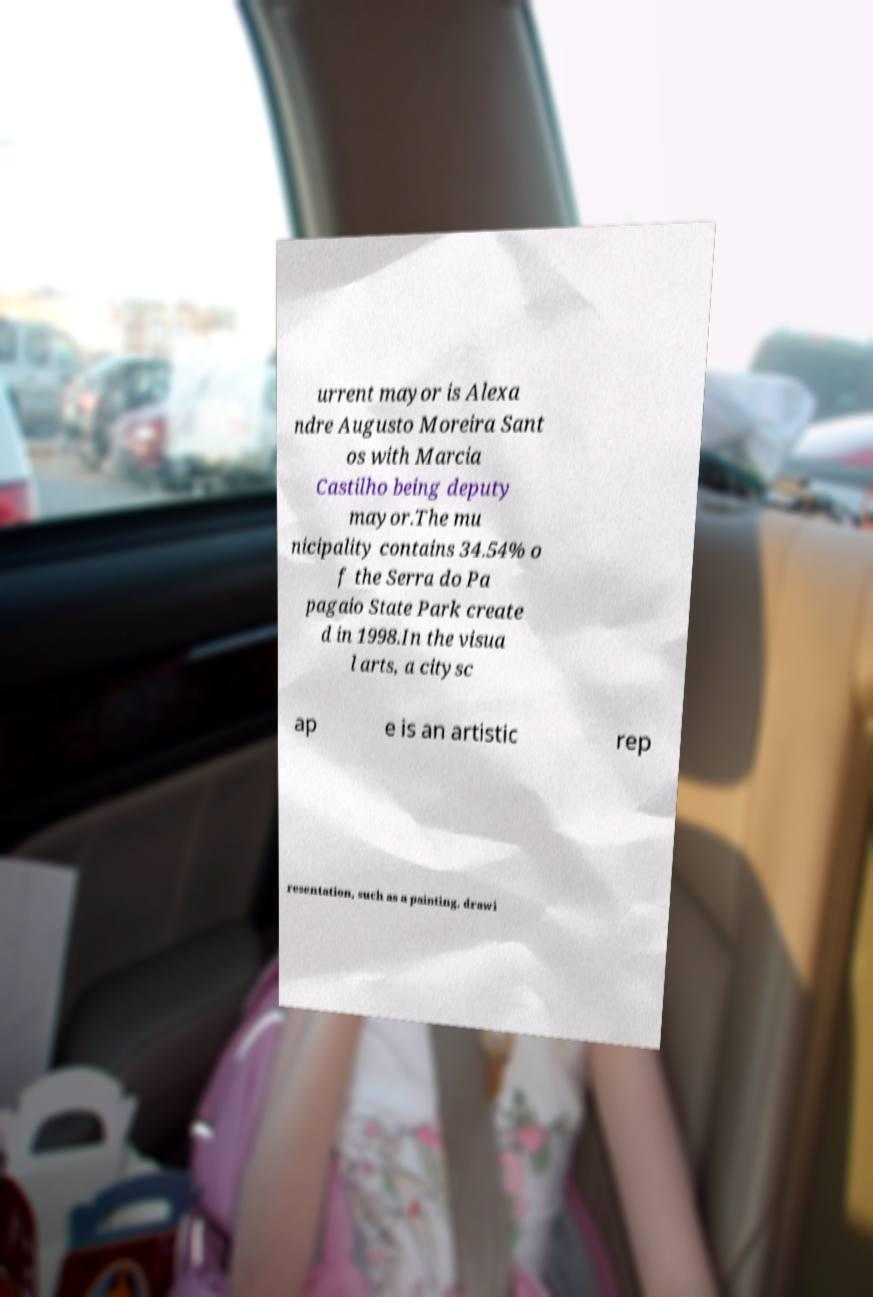I need the written content from this picture converted into text. Can you do that? urrent mayor is Alexa ndre Augusto Moreira Sant os with Marcia Castilho being deputy mayor.The mu nicipality contains 34.54% o f the Serra do Pa pagaio State Park create d in 1998.In the visua l arts, a citysc ap e is an artistic rep resentation, such as a painting, drawi 